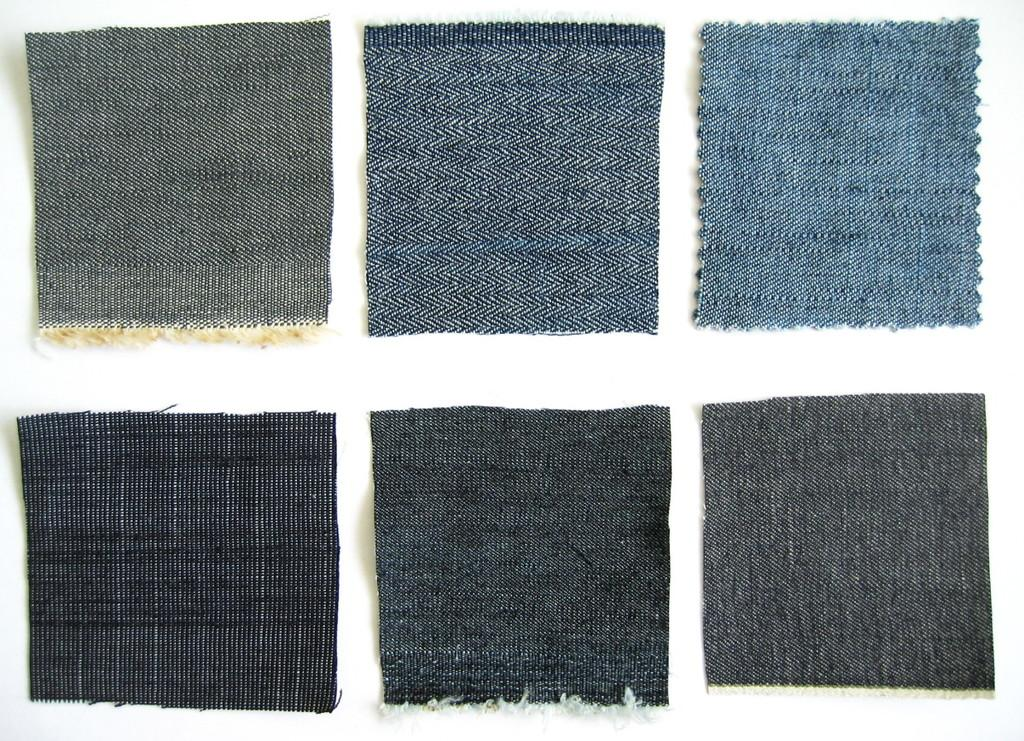What type of objects can be seen in the image? There are pieces of clothes in the image. Where are the clothes placed in the image? The clothes are on a white surface. What type of map can be seen in the image? There is no map present in the image. What color is the yarn used to create the jellyfish in the image? There is no yarn or jellyfish present in the image. 